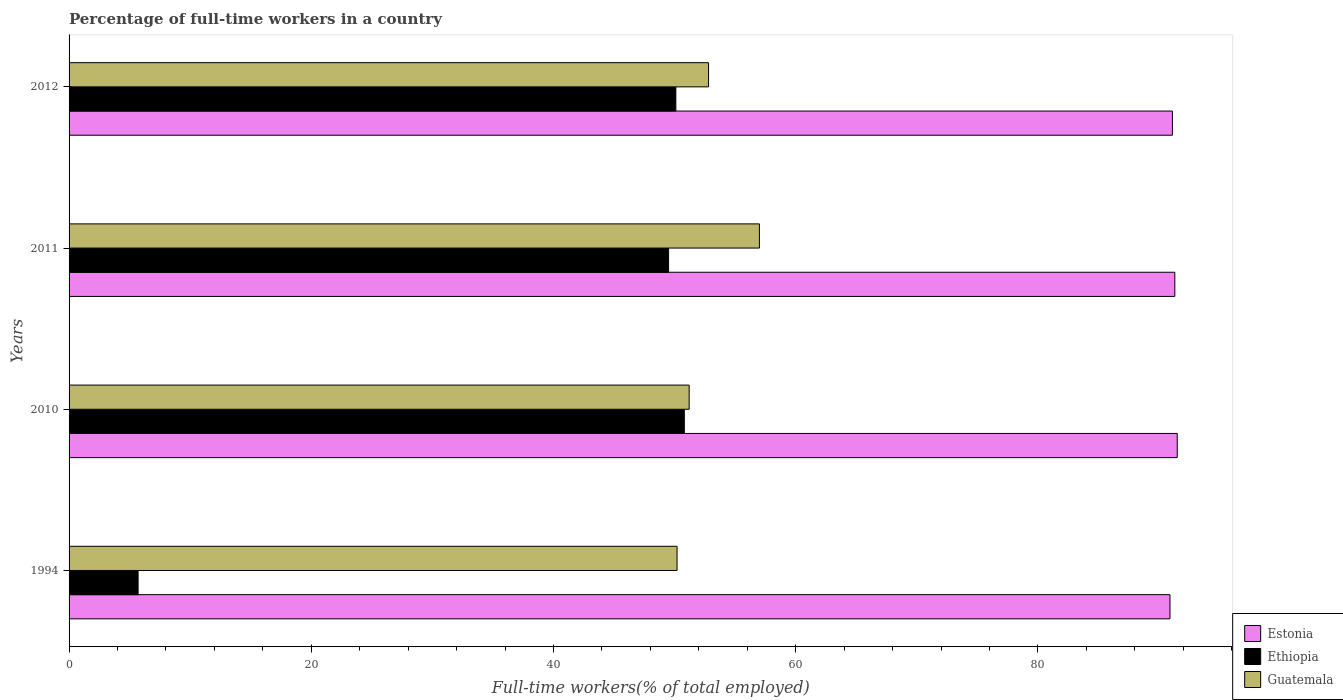How many groups of bars are there?
Keep it short and to the point. 4. Are the number of bars per tick equal to the number of legend labels?
Make the answer very short. Yes. What is the label of the 2nd group of bars from the top?
Keep it short and to the point. 2011. What is the percentage of full-time workers in Estonia in 2011?
Offer a terse response. 91.3. Across all years, what is the maximum percentage of full-time workers in Estonia?
Make the answer very short. 91.5. Across all years, what is the minimum percentage of full-time workers in Guatemala?
Provide a short and direct response. 50.2. In which year was the percentage of full-time workers in Ethiopia minimum?
Your response must be concise. 1994. What is the total percentage of full-time workers in Estonia in the graph?
Provide a succinct answer. 364.8. What is the difference between the percentage of full-time workers in Ethiopia in 2011 and that in 2012?
Give a very brief answer. -0.6. What is the difference between the percentage of full-time workers in Guatemala in 2010 and the percentage of full-time workers in Estonia in 1994?
Your answer should be compact. -39.7. What is the average percentage of full-time workers in Guatemala per year?
Make the answer very short. 52.8. In the year 2012, what is the difference between the percentage of full-time workers in Ethiopia and percentage of full-time workers in Guatemala?
Provide a short and direct response. -2.7. What is the ratio of the percentage of full-time workers in Guatemala in 1994 to that in 2012?
Offer a very short reply. 0.95. Is the difference between the percentage of full-time workers in Ethiopia in 2011 and 2012 greater than the difference between the percentage of full-time workers in Guatemala in 2011 and 2012?
Provide a succinct answer. No. What is the difference between the highest and the second highest percentage of full-time workers in Ethiopia?
Your answer should be compact. 0.7. What is the difference between the highest and the lowest percentage of full-time workers in Estonia?
Ensure brevity in your answer.  0.6. In how many years, is the percentage of full-time workers in Estonia greater than the average percentage of full-time workers in Estonia taken over all years?
Make the answer very short. 2. Is the sum of the percentage of full-time workers in Guatemala in 1994 and 2010 greater than the maximum percentage of full-time workers in Ethiopia across all years?
Offer a terse response. Yes. What does the 2nd bar from the top in 1994 represents?
Offer a very short reply. Ethiopia. What does the 2nd bar from the bottom in 2012 represents?
Your response must be concise. Ethiopia. Is it the case that in every year, the sum of the percentage of full-time workers in Ethiopia and percentage of full-time workers in Guatemala is greater than the percentage of full-time workers in Estonia?
Give a very brief answer. No. Are all the bars in the graph horizontal?
Offer a very short reply. Yes. How many years are there in the graph?
Provide a short and direct response. 4. Are the values on the major ticks of X-axis written in scientific E-notation?
Provide a short and direct response. No. Does the graph contain any zero values?
Offer a terse response. No. Where does the legend appear in the graph?
Offer a very short reply. Bottom right. How are the legend labels stacked?
Keep it short and to the point. Vertical. What is the title of the graph?
Give a very brief answer. Percentage of full-time workers in a country. Does "Eritrea" appear as one of the legend labels in the graph?
Your answer should be compact. No. What is the label or title of the X-axis?
Provide a short and direct response. Full-time workers(% of total employed). What is the label or title of the Y-axis?
Provide a short and direct response. Years. What is the Full-time workers(% of total employed) in Estonia in 1994?
Give a very brief answer. 90.9. What is the Full-time workers(% of total employed) in Ethiopia in 1994?
Your answer should be very brief. 5.7. What is the Full-time workers(% of total employed) in Guatemala in 1994?
Provide a short and direct response. 50.2. What is the Full-time workers(% of total employed) of Estonia in 2010?
Make the answer very short. 91.5. What is the Full-time workers(% of total employed) in Ethiopia in 2010?
Ensure brevity in your answer.  50.8. What is the Full-time workers(% of total employed) of Guatemala in 2010?
Provide a short and direct response. 51.2. What is the Full-time workers(% of total employed) in Estonia in 2011?
Offer a terse response. 91.3. What is the Full-time workers(% of total employed) of Ethiopia in 2011?
Provide a succinct answer. 49.5. What is the Full-time workers(% of total employed) of Guatemala in 2011?
Give a very brief answer. 57. What is the Full-time workers(% of total employed) in Estonia in 2012?
Ensure brevity in your answer.  91.1. What is the Full-time workers(% of total employed) of Ethiopia in 2012?
Give a very brief answer. 50.1. What is the Full-time workers(% of total employed) of Guatemala in 2012?
Keep it short and to the point. 52.8. Across all years, what is the maximum Full-time workers(% of total employed) of Estonia?
Provide a succinct answer. 91.5. Across all years, what is the maximum Full-time workers(% of total employed) of Ethiopia?
Ensure brevity in your answer.  50.8. Across all years, what is the minimum Full-time workers(% of total employed) of Estonia?
Keep it short and to the point. 90.9. Across all years, what is the minimum Full-time workers(% of total employed) in Ethiopia?
Provide a succinct answer. 5.7. Across all years, what is the minimum Full-time workers(% of total employed) of Guatemala?
Offer a very short reply. 50.2. What is the total Full-time workers(% of total employed) of Estonia in the graph?
Offer a terse response. 364.8. What is the total Full-time workers(% of total employed) in Ethiopia in the graph?
Your answer should be compact. 156.1. What is the total Full-time workers(% of total employed) of Guatemala in the graph?
Your answer should be compact. 211.2. What is the difference between the Full-time workers(% of total employed) of Ethiopia in 1994 and that in 2010?
Your answer should be compact. -45.1. What is the difference between the Full-time workers(% of total employed) in Ethiopia in 1994 and that in 2011?
Provide a succinct answer. -43.8. What is the difference between the Full-time workers(% of total employed) in Guatemala in 1994 and that in 2011?
Provide a short and direct response. -6.8. What is the difference between the Full-time workers(% of total employed) in Estonia in 1994 and that in 2012?
Offer a very short reply. -0.2. What is the difference between the Full-time workers(% of total employed) of Ethiopia in 1994 and that in 2012?
Your answer should be very brief. -44.4. What is the difference between the Full-time workers(% of total employed) of Guatemala in 2010 and that in 2011?
Give a very brief answer. -5.8. What is the difference between the Full-time workers(% of total employed) of Estonia in 2010 and that in 2012?
Give a very brief answer. 0.4. What is the difference between the Full-time workers(% of total employed) in Estonia in 2011 and that in 2012?
Your response must be concise. 0.2. What is the difference between the Full-time workers(% of total employed) of Ethiopia in 2011 and that in 2012?
Keep it short and to the point. -0.6. What is the difference between the Full-time workers(% of total employed) of Estonia in 1994 and the Full-time workers(% of total employed) of Ethiopia in 2010?
Your response must be concise. 40.1. What is the difference between the Full-time workers(% of total employed) of Estonia in 1994 and the Full-time workers(% of total employed) of Guatemala in 2010?
Keep it short and to the point. 39.7. What is the difference between the Full-time workers(% of total employed) in Ethiopia in 1994 and the Full-time workers(% of total employed) in Guatemala in 2010?
Offer a very short reply. -45.5. What is the difference between the Full-time workers(% of total employed) of Estonia in 1994 and the Full-time workers(% of total employed) of Ethiopia in 2011?
Provide a short and direct response. 41.4. What is the difference between the Full-time workers(% of total employed) of Estonia in 1994 and the Full-time workers(% of total employed) of Guatemala in 2011?
Provide a succinct answer. 33.9. What is the difference between the Full-time workers(% of total employed) in Ethiopia in 1994 and the Full-time workers(% of total employed) in Guatemala in 2011?
Your response must be concise. -51.3. What is the difference between the Full-time workers(% of total employed) in Estonia in 1994 and the Full-time workers(% of total employed) in Ethiopia in 2012?
Make the answer very short. 40.8. What is the difference between the Full-time workers(% of total employed) of Estonia in 1994 and the Full-time workers(% of total employed) of Guatemala in 2012?
Your answer should be very brief. 38.1. What is the difference between the Full-time workers(% of total employed) of Ethiopia in 1994 and the Full-time workers(% of total employed) of Guatemala in 2012?
Keep it short and to the point. -47.1. What is the difference between the Full-time workers(% of total employed) of Estonia in 2010 and the Full-time workers(% of total employed) of Guatemala in 2011?
Provide a short and direct response. 34.5. What is the difference between the Full-time workers(% of total employed) of Ethiopia in 2010 and the Full-time workers(% of total employed) of Guatemala in 2011?
Your answer should be very brief. -6.2. What is the difference between the Full-time workers(% of total employed) in Estonia in 2010 and the Full-time workers(% of total employed) in Ethiopia in 2012?
Provide a short and direct response. 41.4. What is the difference between the Full-time workers(% of total employed) in Estonia in 2010 and the Full-time workers(% of total employed) in Guatemala in 2012?
Keep it short and to the point. 38.7. What is the difference between the Full-time workers(% of total employed) of Ethiopia in 2010 and the Full-time workers(% of total employed) of Guatemala in 2012?
Your response must be concise. -2. What is the difference between the Full-time workers(% of total employed) in Estonia in 2011 and the Full-time workers(% of total employed) in Ethiopia in 2012?
Give a very brief answer. 41.2. What is the difference between the Full-time workers(% of total employed) in Estonia in 2011 and the Full-time workers(% of total employed) in Guatemala in 2012?
Keep it short and to the point. 38.5. What is the difference between the Full-time workers(% of total employed) in Ethiopia in 2011 and the Full-time workers(% of total employed) in Guatemala in 2012?
Provide a short and direct response. -3.3. What is the average Full-time workers(% of total employed) in Estonia per year?
Your answer should be compact. 91.2. What is the average Full-time workers(% of total employed) of Ethiopia per year?
Your answer should be compact. 39.02. What is the average Full-time workers(% of total employed) of Guatemala per year?
Make the answer very short. 52.8. In the year 1994, what is the difference between the Full-time workers(% of total employed) in Estonia and Full-time workers(% of total employed) in Ethiopia?
Offer a very short reply. 85.2. In the year 1994, what is the difference between the Full-time workers(% of total employed) in Estonia and Full-time workers(% of total employed) in Guatemala?
Ensure brevity in your answer.  40.7. In the year 1994, what is the difference between the Full-time workers(% of total employed) of Ethiopia and Full-time workers(% of total employed) of Guatemala?
Give a very brief answer. -44.5. In the year 2010, what is the difference between the Full-time workers(% of total employed) of Estonia and Full-time workers(% of total employed) of Ethiopia?
Keep it short and to the point. 40.7. In the year 2010, what is the difference between the Full-time workers(% of total employed) in Estonia and Full-time workers(% of total employed) in Guatemala?
Your answer should be compact. 40.3. In the year 2010, what is the difference between the Full-time workers(% of total employed) in Ethiopia and Full-time workers(% of total employed) in Guatemala?
Give a very brief answer. -0.4. In the year 2011, what is the difference between the Full-time workers(% of total employed) of Estonia and Full-time workers(% of total employed) of Ethiopia?
Offer a terse response. 41.8. In the year 2011, what is the difference between the Full-time workers(% of total employed) of Estonia and Full-time workers(% of total employed) of Guatemala?
Your answer should be compact. 34.3. In the year 2011, what is the difference between the Full-time workers(% of total employed) of Ethiopia and Full-time workers(% of total employed) of Guatemala?
Your answer should be compact. -7.5. In the year 2012, what is the difference between the Full-time workers(% of total employed) in Estonia and Full-time workers(% of total employed) in Guatemala?
Make the answer very short. 38.3. In the year 2012, what is the difference between the Full-time workers(% of total employed) of Ethiopia and Full-time workers(% of total employed) of Guatemala?
Your answer should be very brief. -2.7. What is the ratio of the Full-time workers(% of total employed) of Ethiopia in 1994 to that in 2010?
Your answer should be compact. 0.11. What is the ratio of the Full-time workers(% of total employed) of Guatemala in 1994 to that in 2010?
Your answer should be very brief. 0.98. What is the ratio of the Full-time workers(% of total employed) in Ethiopia in 1994 to that in 2011?
Provide a short and direct response. 0.12. What is the ratio of the Full-time workers(% of total employed) of Guatemala in 1994 to that in 2011?
Give a very brief answer. 0.88. What is the ratio of the Full-time workers(% of total employed) in Estonia in 1994 to that in 2012?
Make the answer very short. 1. What is the ratio of the Full-time workers(% of total employed) of Ethiopia in 1994 to that in 2012?
Offer a terse response. 0.11. What is the ratio of the Full-time workers(% of total employed) of Guatemala in 1994 to that in 2012?
Your answer should be very brief. 0.95. What is the ratio of the Full-time workers(% of total employed) of Ethiopia in 2010 to that in 2011?
Provide a short and direct response. 1.03. What is the ratio of the Full-time workers(% of total employed) of Guatemala in 2010 to that in 2011?
Give a very brief answer. 0.9. What is the ratio of the Full-time workers(% of total employed) of Guatemala in 2010 to that in 2012?
Keep it short and to the point. 0.97. What is the ratio of the Full-time workers(% of total employed) in Guatemala in 2011 to that in 2012?
Your answer should be compact. 1.08. What is the difference between the highest and the lowest Full-time workers(% of total employed) of Estonia?
Your response must be concise. 0.6. What is the difference between the highest and the lowest Full-time workers(% of total employed) in Ethiopia?
Your answer should be compact. 45.1. 